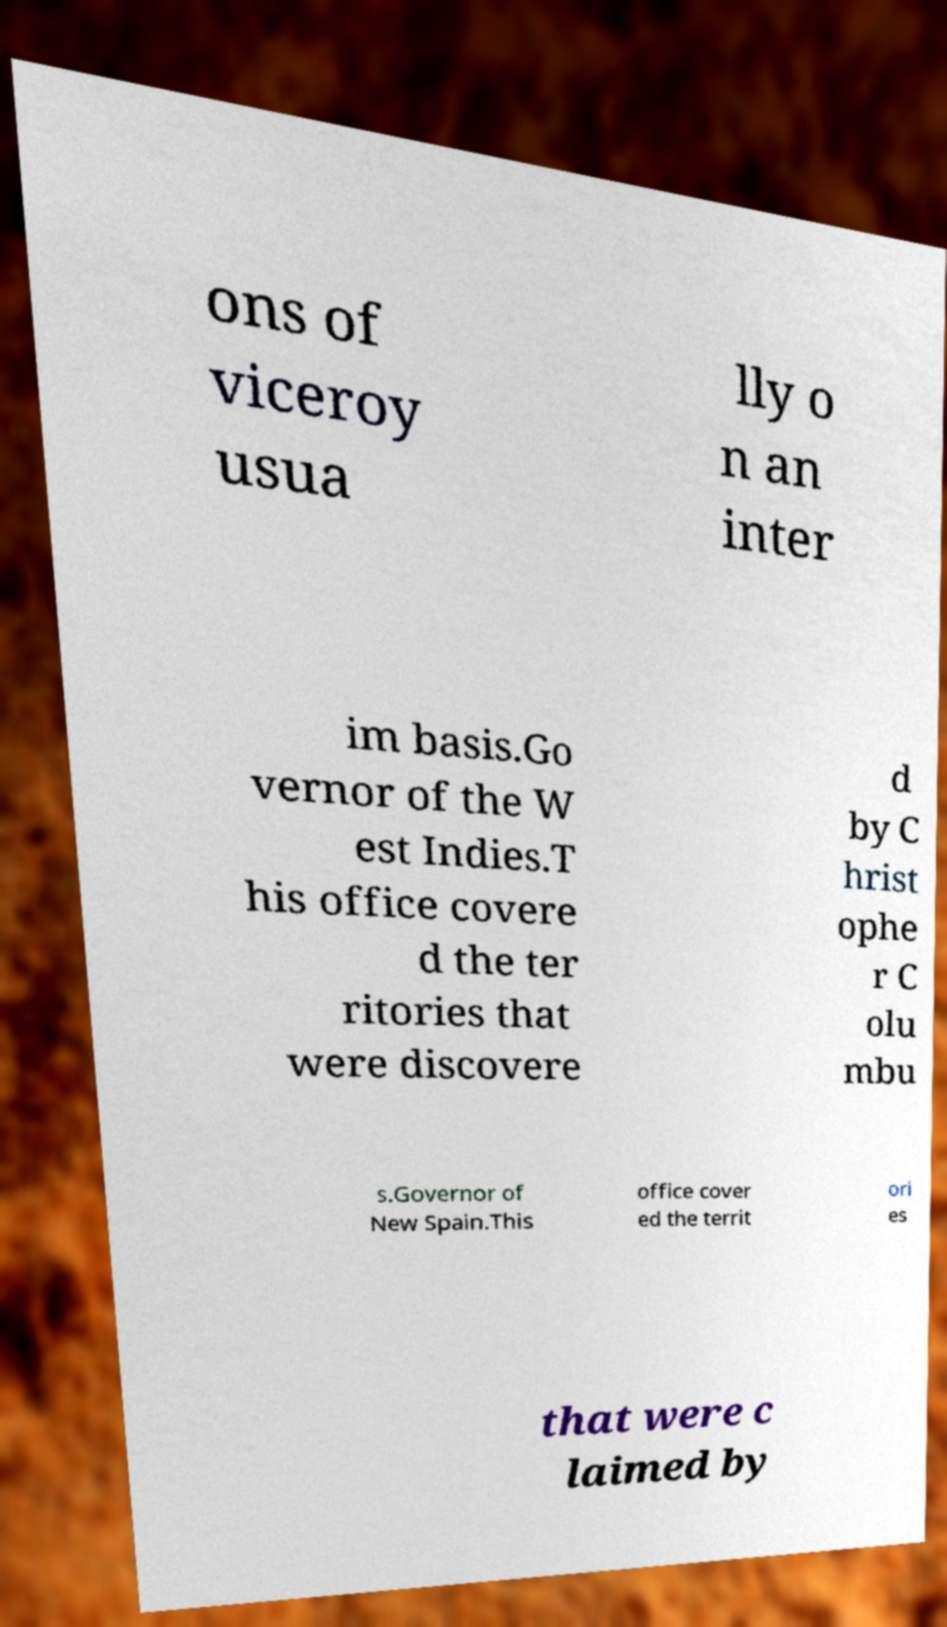Can you read and provide the text displayed in the image?This photo seems to have some interesting text. Can you extract and type it out for me? ons of viceroy usua lly o n an inter im basis.Go vernor of the W est Indies.T his office covere d the ter ritories that were discovere d by C hrist ophe r C olu mbu s.Governor of New Spain.This office cover ed the territ ori es that were c laimed by 